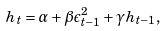Convert formula to latex. <formula><loc_0><loc_0><loc_500><loc_500>h _ { t } = \alpha + \beta \epsilon _ { t - 1 } ^ { 2 } + \gamma h _ { t - 1 } ,</formula> 